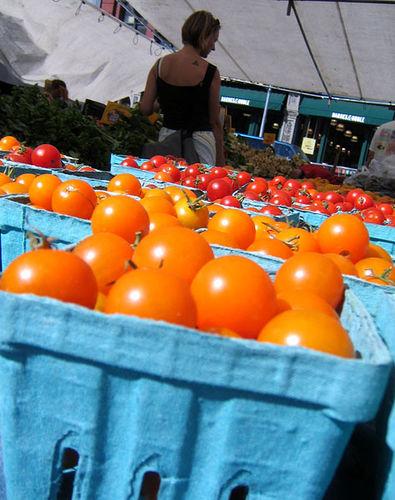What are the tomatoes contained in?
Keep it brief. Cartons. What is on display?
Answer briefly. Tomatoes. What is the roof made of?
Quick response, please. Canvas. 